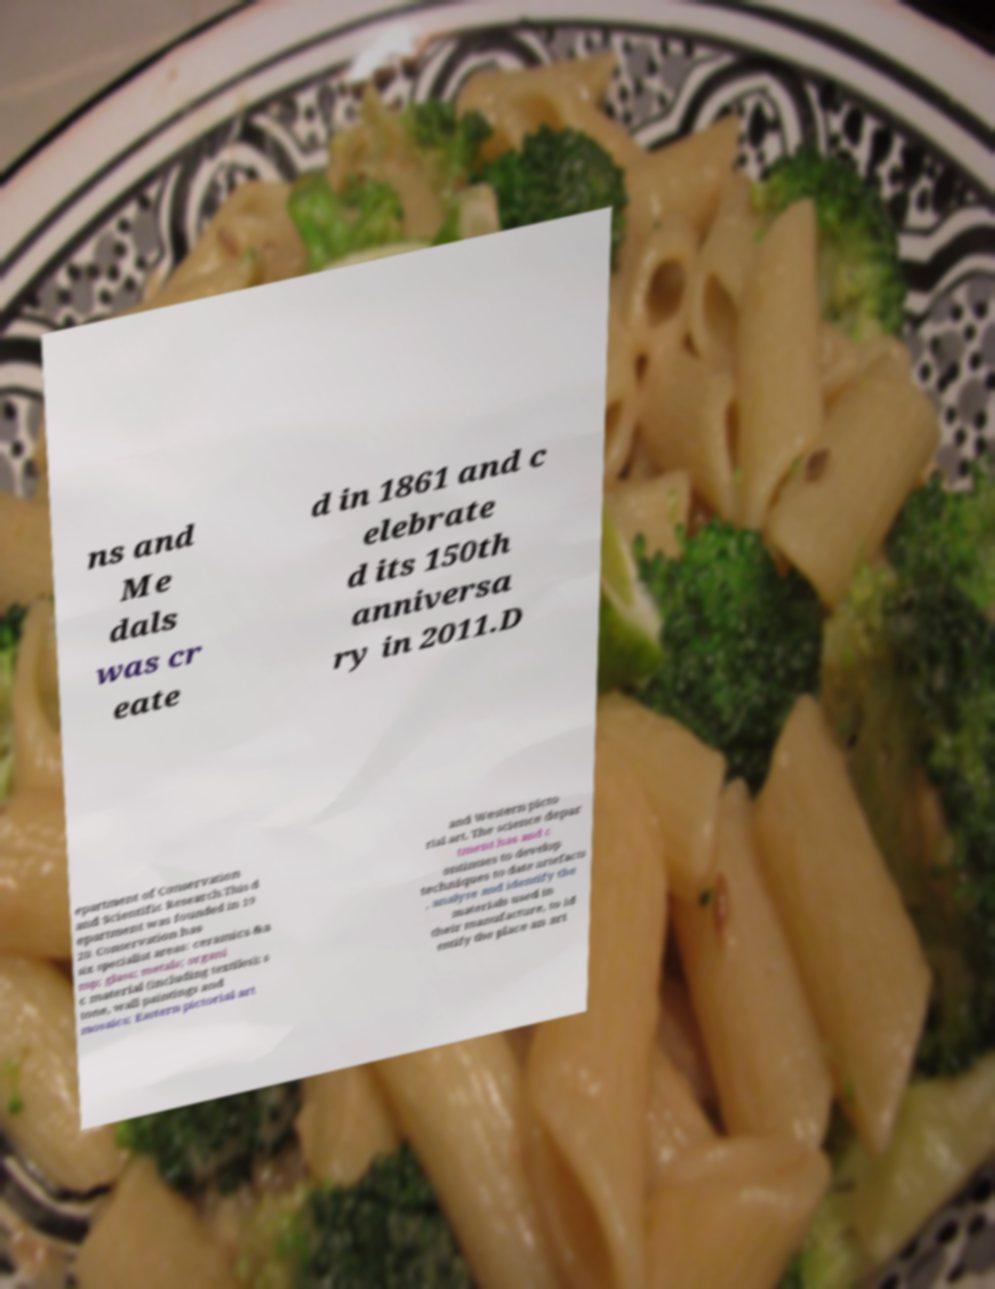Please read and relay the text visible in this image. What does it say? ns and Me dals was cr eate d in 1861 and c elebrate d its 150th anniversa ry in 2011.D epartment of Conservation and Scientific Research.This d epartment was founded in 19 20. Conservation has six specialist areas: ceramics &a mp; glass; metals; organi c material (including textiles); s tone, wall paintings and mosaics; Eastern pictorial art and Western picto rial art. The science depar tment has and c ontinues to develop techniques to date artefacts , analyse and identify the materials used in their manufacture, to id entify the place an art 